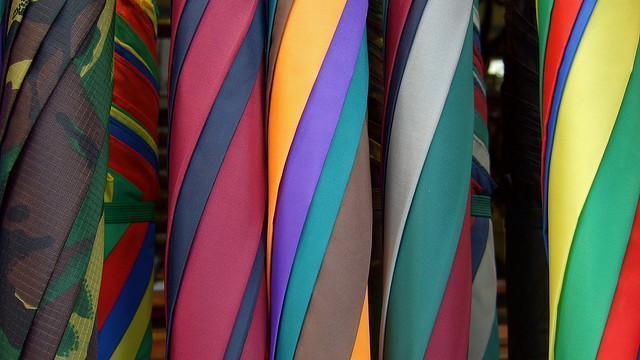How many umbrellas are in the photo?
Give a very brief answer. 6. 